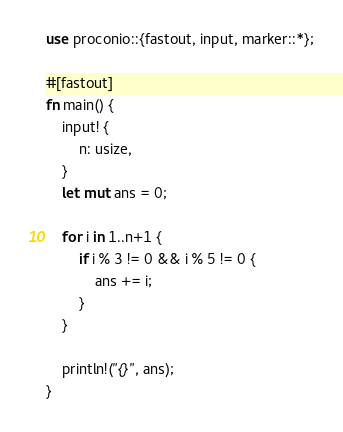Convert code to text. <code><loc_0><loc_0><loc_500><loc_500><_Rust_>use proconio::{fastout, input, marker::*};

#[fastout]
fn main() {
    input! {
        n: usize,
    }
    let mut ans = 0;

    for i in 1..n+1 {
        if i % 3 != 0 && i % 5 != 0 {
            ans += i;
        }
    }

    println!("{}", ans);
}
</code> 